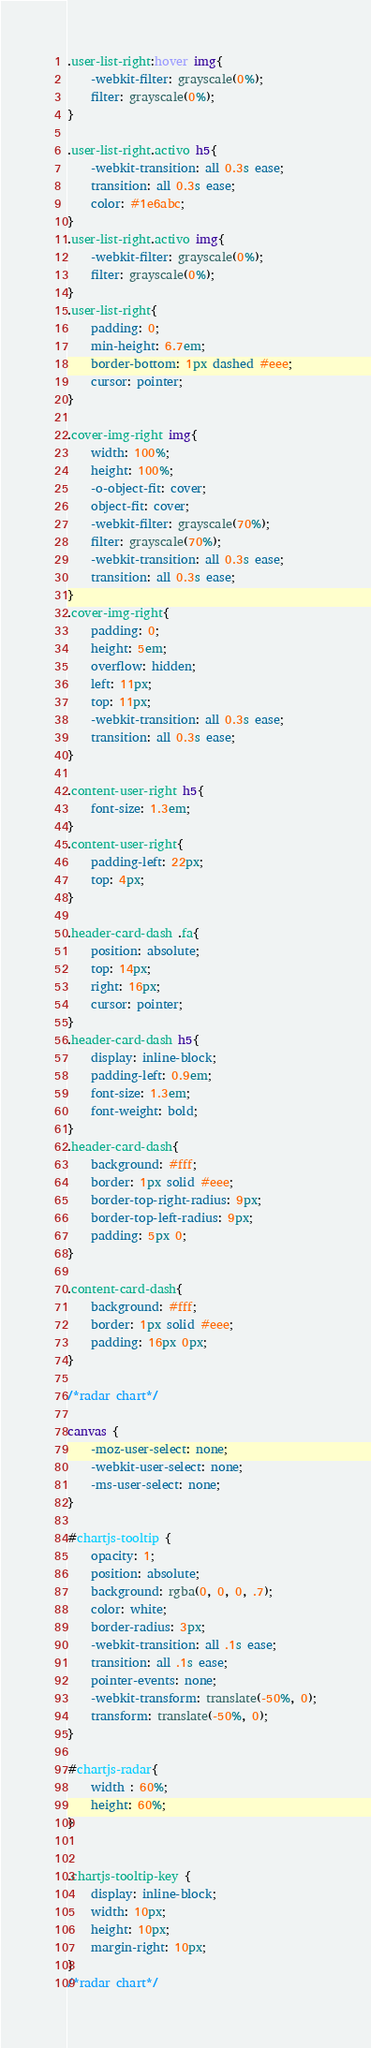<code> <loc_0><loc_0><loc_500><loc_500><_CSS_>.user-list-right:hover img{
    -webkit-filter: grayscale(0%);
    filter: grayscale(0%);
}

.user-list-right.activo h5{
    -webkit-transition: all 0.3s ease;
    transition: all 0.3s ease;
    color: #1e6abc;
}
.user-list-right.activo img{
    -webkit-filter: grayscale(0%);
    filter: grayscale(0%);
}
.user-list-right{
    padding: 0;
    min-height: 6.7em;
    border-bottom: 1px dashed #eee;
    cursor: pointer;
}

.cover-img-right img{
    width: 100%;
    height: 100%;
    -o-object-fit: cover;
    object-fit: cover;
    -webkit-filter: grayscale(70%);
    filter: grayscale(70%);
    -webkit-transition: all 0.3s ease;
    transition: all 0.3s ease;
}
.cover-img-right{
    padding: 0;
    height: 5em;
    overflow: hidden;
    left: 11px;
    top: 11px;
    -webkit-transition: all 0.3s ease;
    transition: all 0.3s ease;
}

.content-user-right h5{
    font-size: 1.3em;
}
.content-user-right{
    padding-left: 22px;
    top: 4px;
}

.header-card-dash .fa{
    position: absolute;
    top: 14px;
    right: 16px;
    cursor: pointer;
}
.header-card-dash h5{
    display: inline-block;
    padding-left: 0.9em;
    font-size: 1.3em;
    font-weight: bold;
}
.header-card-dash{
    background: #fff;
    border: 1px solid #eee;
    border-top-right-radius: 9px;
    border-top-left-radius: 9px;
    padding: 5px 0;
}

.content-card-dash{
    background: #fff;
    border: 1px solid #eee;
    padding: 16px 0px;
}

/*radar chart*/

canvas {
    -moz-user-select: none;
    -webkit-user-select: none;
    -ms-user-select: none;
}

#chartjs-tooltip {
    opacity: 1;
    position: absolute;
    background: rgba(0, 0, 0, .7);
    color: white;
    border-radius: 3px;
    -webkit-transition: all .1s ease;
    transition: all .1s ease;
    pointer-events: none;
    -webkit-transform: translate(-50%, 0);
    transform: translate(-50%, 0);
}

#chartjs-radar{
    width : 60%;
    height: 60%;
}


.chartjs-tooltip-key {
    display: inline-block;
    width: 10px;
    height: 10px;
    margin-right: 10px;
}
/*radar chart*/
</code> 